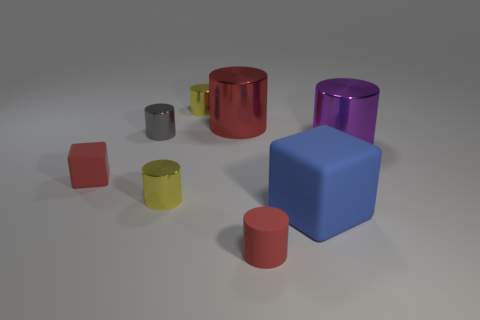There is a small cylinder that is the same color as the tiny cube; what is it made of?
Your answer should be compact. Rubber. Do the red cube and the red matte thing that is in front of the blue matte block have the same size?
Your answer should be compact. Yes. Are there any rubber objects that have the same color as the small matte cylinder?
Provide a short and direct response. Yes. What is the size of the gray object that is made of the same material as the purple cylinder?
Keep it short and to the point. Small. Do the blue block and the gray object have the same material?
Your answer should be very brief. No. The big cylinder that is right of the tiny object that is in front of the yellow metallic cylinder in front of the tiny gray thing is what color?
Make the answer very short. Purple. What shape is the red metallic object?
Offer a very short reply. Cylinder. Do the tiny cube and the large metal object behind the purple cylinder have the same color?
Offer a terse response. Yes. Are there the same number of small gray cylinders that are on the right side of the small red rubber cylinder and red metal objects?
Keep it short and to the point. No. How many objects are the same size as the red rubber cylinder?
Provide a succinct answer. 4. 